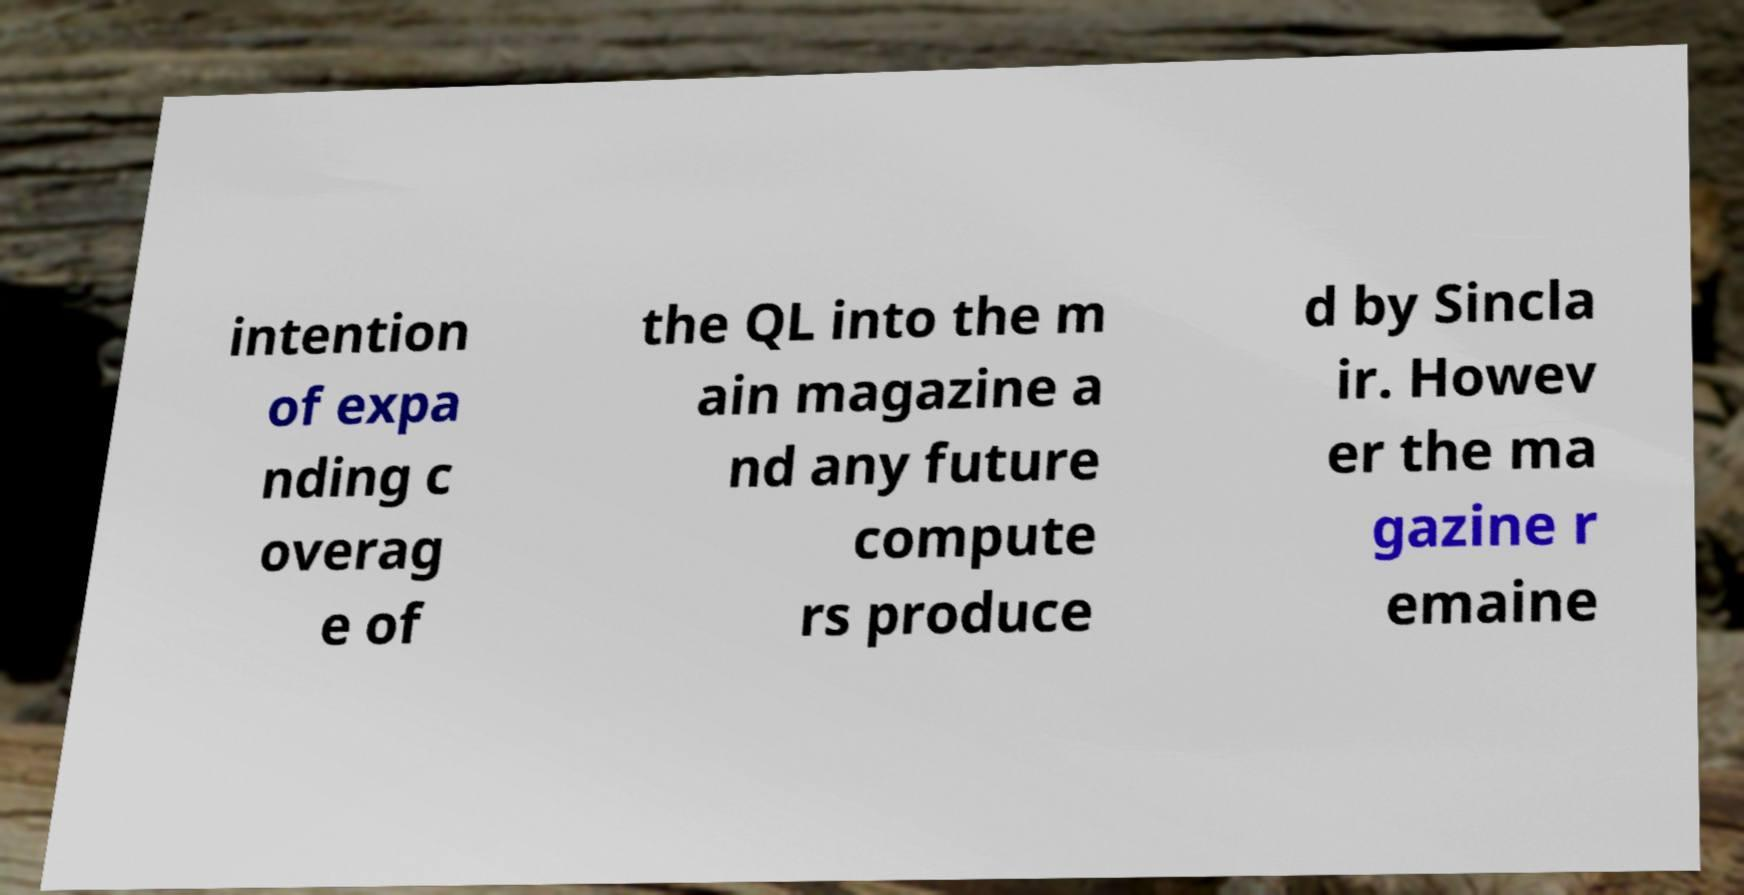There's text embedded in this image that I need extracted. Can you transcribe it verbatim? intention of expa nding c overag e of the QL into the m ain magazine a nd any future compute rs produce d by Sincla ir. Howev er the ma gazine r emaine 